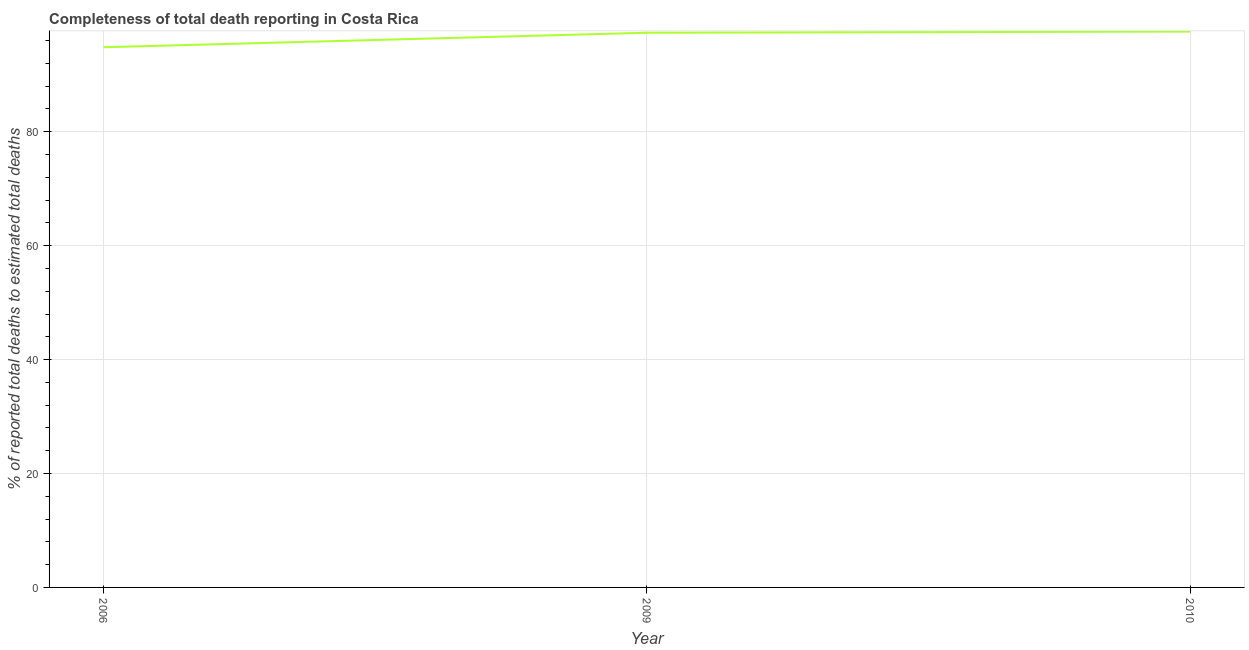What is the completeness of total death reports in 2009?
Provide a short and direct response. 97.38. Across all years, what is the maximum completeness of total death reports?
Give a very brief answer. 97.58. Across all years, what is the minimum completeness of total death reports?
Your answer should be compact. 94.84. In which year was the completeness of total death reports maximum?
Keep it short and to the point. 2010. What is the sum of the completeness of total death reports?
Ensure brevity in your answer.  289.8. What is the difference between the completeness of total death reports in 2006 and 2010?
Offer a terse response. -2.74. What is the average completeness of total death reports per year?
Provide a succinct answer. 96.6. What is the median completeness of total death reports?
Keep it short and to the point. 97.38. In how many years, is the completeness of total death reports greater than 32 %?
Make the answer very short. 3. Do a majority of the years between 2010 and 2006 (inclusive) have completeness of total death reports greater than 4 %?
Make the answer very short. No. What is the ratio of the completeness of total death reports in 2006 to that in 2010?
Offer a terse response. 0.97. Is the difference between the completeness of total death reports in 2006 and 2010 greater than the difference between any two years?
Give a very brief answer. Yes. What is the difference between the highest and the second highest completeness of total death reports?
Provide a short and direct response. 0.2. Is the sum of the completeness of total death reports in 2006 and 2010 greater than the maximum completeness of total death reports across all years?
Your answer should be very brief. Yes. What is the difference between the highest and the lowest completeness of total death reports?
Your answer should be compact. 2.74. Does the completeness of total death reports monotonically increase over the years?
Make the answer very short. Yes. How many lines are there?
Give a very brief answer. 1. Does the graph contain grids?
Make the answer very short. Yes. What is the title of the graph?
Give a very brief answer. Completeness of total death reporting in Costa Rica. What is the label or title of the Y-axis?
Make the answer very short. % of reported total deaths to estimated total deaths. What is the % of reported total deaths to estimated total deaths in 2006?
Offer a very short reply. 94.84. What is the % of reported total deaths to estimated total deaths of 2009?
Offer a very short reply. 97.38. What is the % of reported total deaths to estimated total deaths of 2010?
Provide a succinct answer. 97.58. What is the difference between the % of reported total deaths to estimated total deaths in 2006 and 2009?
Your answer should be very brief. -2.55. What is the difference between the % of reported total deaths to estimated total deaths in 2006 and 2010?
Offer a terse response. -2.74. What is the difference between the % of reported total deaths to estimated total deaths in 2009 and 2010?
Keep it short and to the point. -0.2. What is the ratio of the % of reported total deaths to estimated total deaths in 2006 to that in 2009?
Your response must be concise. 0.97. What is the ratio of the % of reported total deaths to estimated total deaths in 2006 to that in 2010?
Give a very brief answer. 0.97. What is the ratio of the % of reported total deaths to estimated total deaths in 2009 to that in 2010?
Your answer should be compact. 1. 